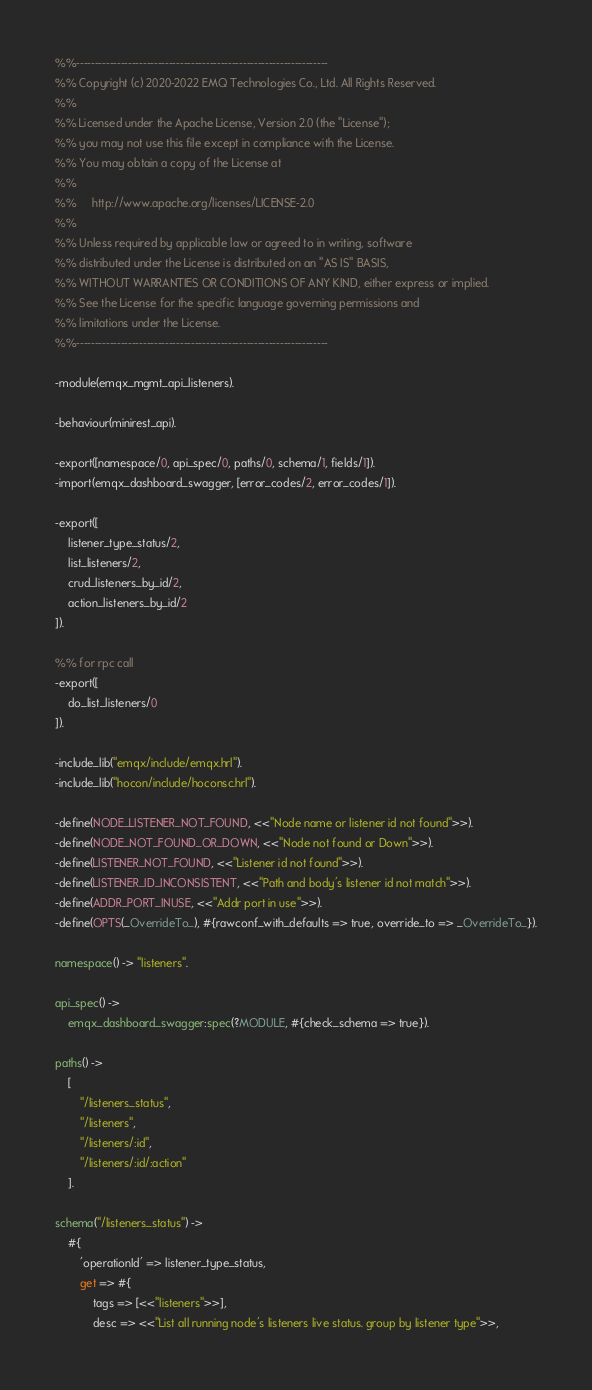Convert code to text. <code><loc_0><loc_0><loc_500><loc_500><_Erlang_>%%--------------------------------------------------------------------
%% Copyright (c) 2020-2022 EMQ Technologies Co., Ltd. All Rights Reserved.
%%
%% Licensed under the Apache License, Version 2.0 (the "License");
%% you may not use this file except in compliance with the License.
%% You may obtain a copy of the License at
%%
%%     http://www.apache.org/licenses/LICENSE-2.0
%%
%% Unless required by applicable law or agreed to in writing, software
%% distributed under the License is distributed on an "AS IS" BASIS,
%% WITHOUT WARRANTIES OR CONDITIONS OF ANY KIND, either express or implied.
%% See the License for the specific language governing permissions and
%% limitations under the License.
%%--------------------------------------------------------------------

-module(emqx_mgmt_api_listeners).

-behaviour(minirest_api).

-export([namespace/0, api_spec/0, paths/0, schema/1, fields/1]).
-import(emqx_dashboard_swagger, [error_codes/2, error_codes/1]).

-export([
    listener_type_status/2,
    list_listeners/2,
    crud_listeners_by_id/2,
    action_listeners_by_id/2
]).

%% for rpc call
-export([
    do_list_listeners/0
]).

-include_lib("emqx/include/emqx.hrl").
-include_lib("hocon/include/hoconsc.hrl").

-define(NODE_LISTENER_NOT_FOUND, <<"Node name or listener id not found">>).
-define(NODE_NOT_FOUND_OR_DOWN, <<"Node not found or Down">>).
-define(LISTENER_NOT_FOUND, <<"Listener id not found">>).
-define(LISTENER_ID_INCONSISTENT, <<"Path and body's listener id not match">>).
-define(ADDR_PORT_INUSE, <<"Addr port in use">>).
-define(OPTS(_OverrideTo_), #{rawconf_with_defaults => true, override_to => _OverrideTo_}).

namespace() -> "listeners".

api_spec() ->
    emqx_dashboard_swagger:spec(?MODULE, #{check_schema => true}).

paths() ->
    [
        "/listeners_status",
        "/listeners",
        "/listeners/:id",
        "/listeners/:id/:action"
    ].

schema("/listeners_status") ->
    #{
        'operationId' => listener_type_status,
        get => #{
            tags => [<<"listeners">>],
            desc => <<"List all running node's listeners live status. group by listener type">>,</code> 